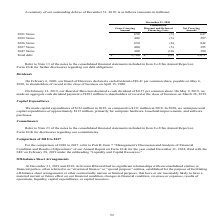According to Activision Blizzard's financial document, What was the gross carrying amount in the 2021 Notes? According to the financial document, 650 (in millions). The relevant text states: "2021 Notes 650 (3) 647..." Also, What was the gross carrying amount in the 2026 Notes? According to the financial document, 850 (in millions). The relevant text states: "2026 Notes 850 (8) 842..." Also, What was the net carrying amount in the 2047 Notes? According to the financial document, 390 (in millions). The relevant text states: "2047 Notes 400 (10) 390..." Also, can you calculate: What was the change in gross carrying amount between the 2022 and 2026 notes? Based on the calculation: 850-400, the result is 450 (in millions). This is based on the information: "2026 Notes 850 (8) 842 2022 Notes 400 (3) 397..." The key data points involved are: 400, 850. Also, can you calculate: What was the change in gross carrying amount between the 2021 and 2022 notes? Based on the calculation: 400-650, the result is -250 (in millions). This is based on the information: "2022 Notes 400 (3) 397 2021 Notes 650 (3) 647..." The key data points involved are: 400, 650. Also, can you calculate: What was the percentage change in the net carrying amount between the 2026 and 2027 notes? To answer this question, I need to perform calculations using the financial data. The calculation is: (395-842)/842, which equals -53.09 (percentage). This is based on the information: "2026 Notes 850 (8) 842 2027 Notes 400 (5) 395..." The key data points involved are: 395, 842. 